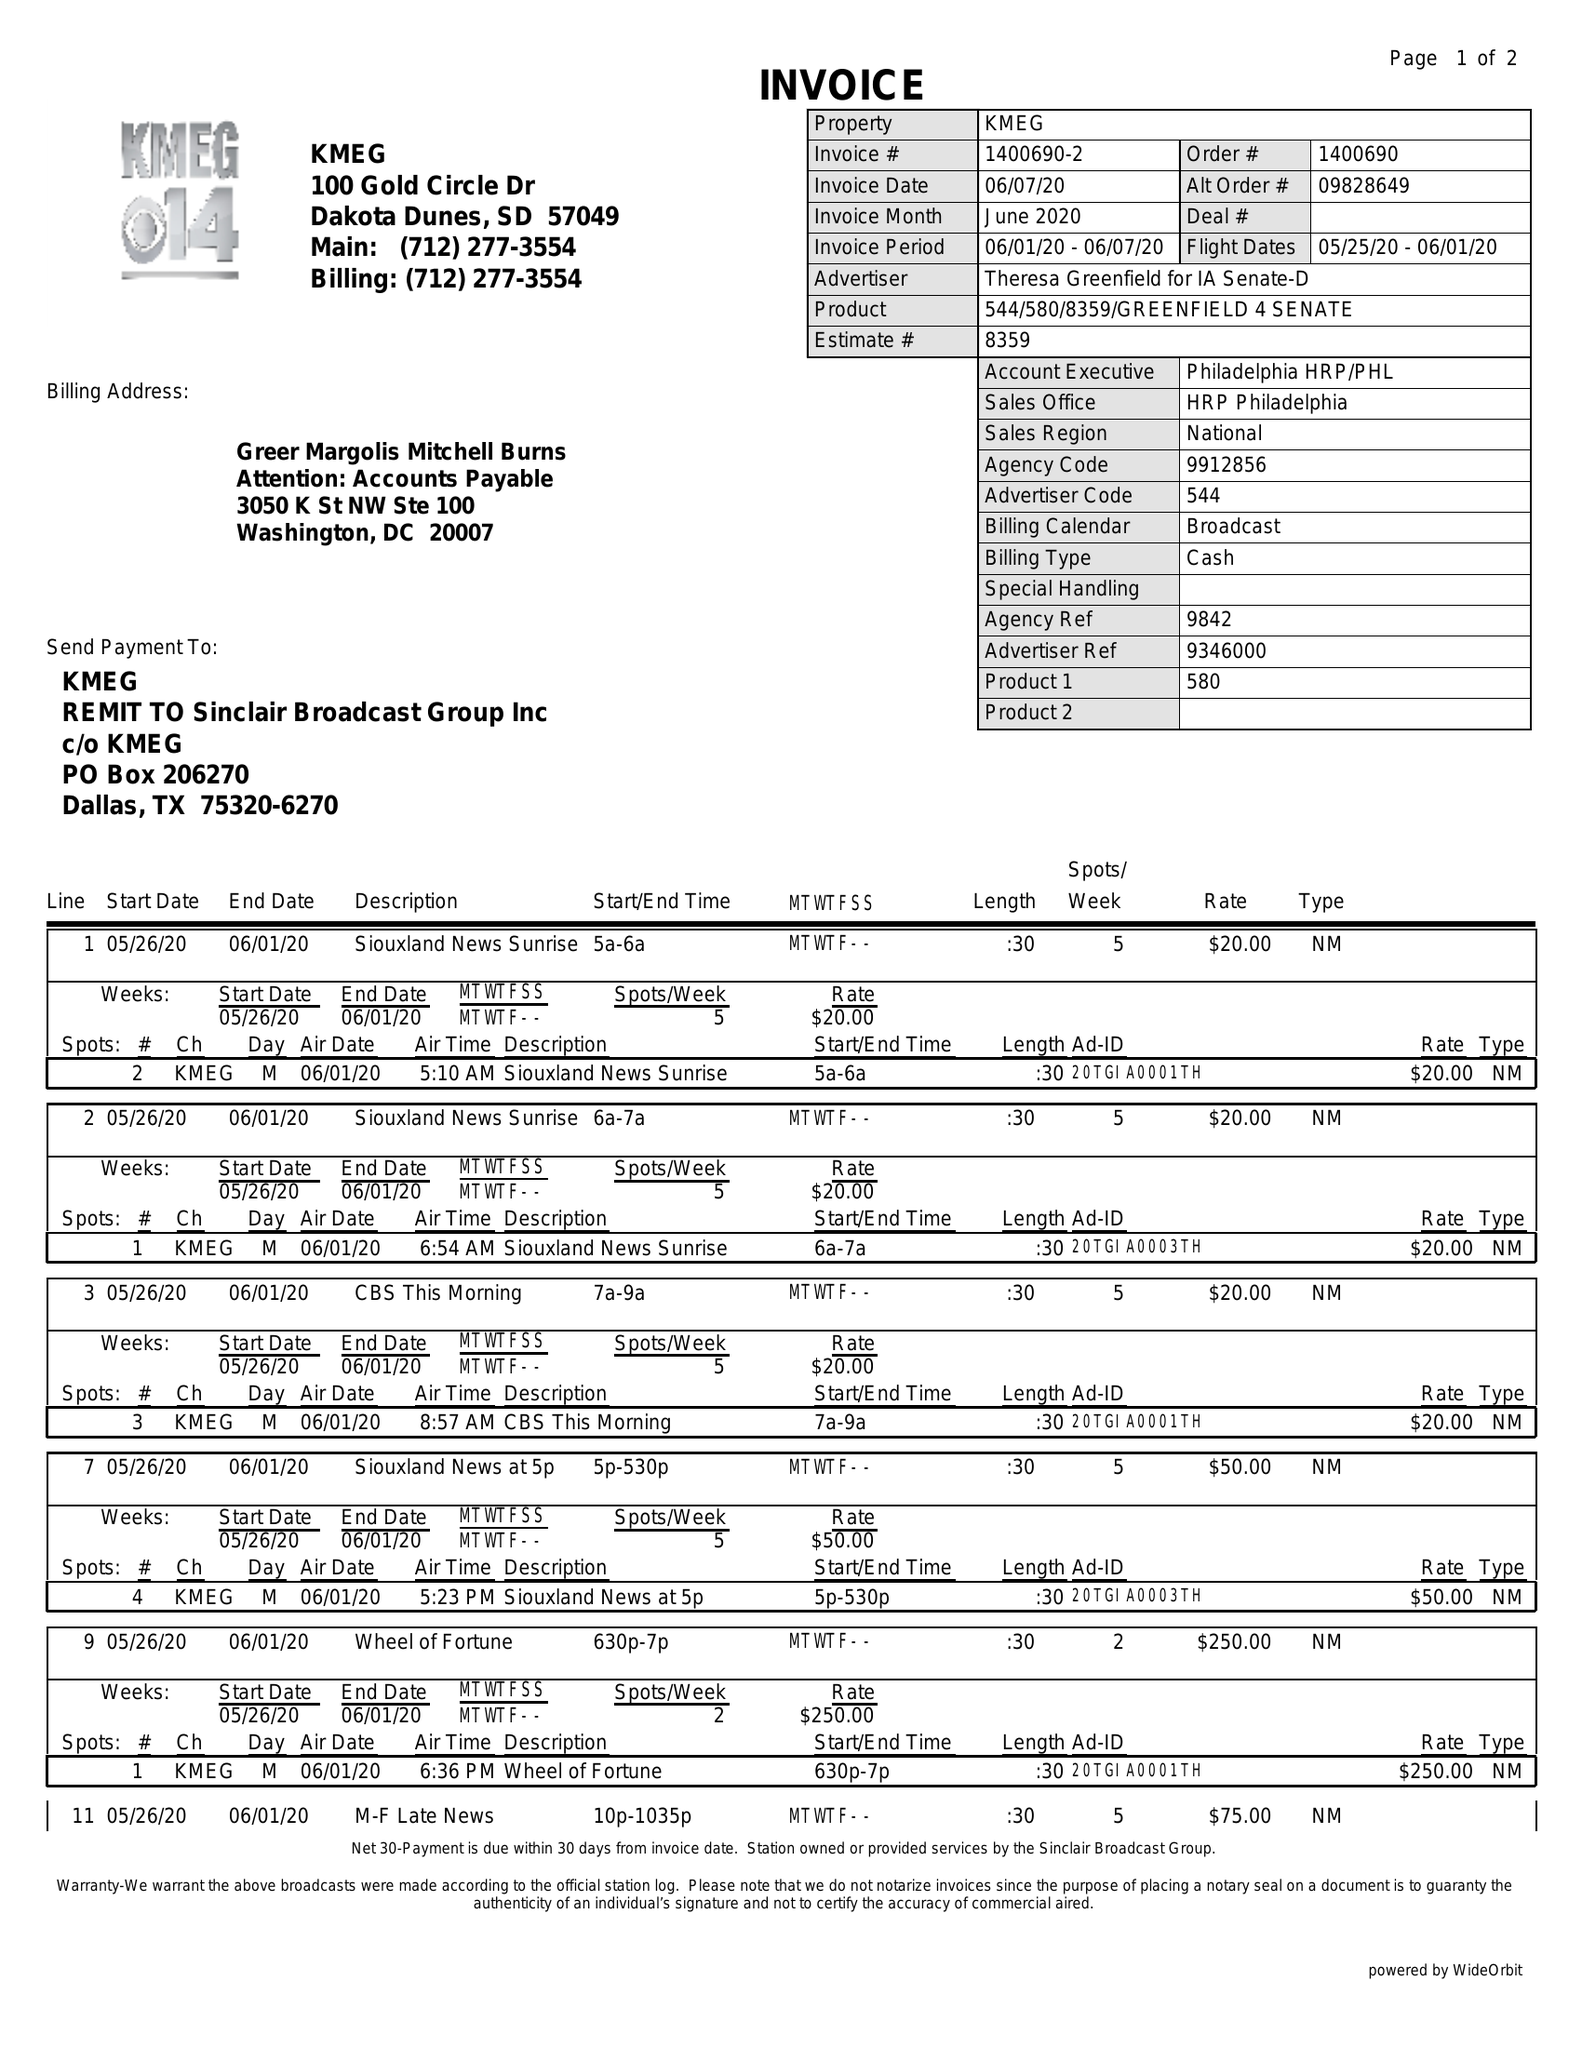What is the value for the flight_to?
Answer the question using a single word or phrase. 06/01/20 